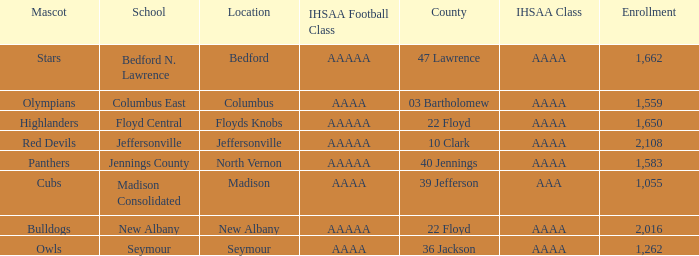What is bedford's mascot? Stars. Can you parse all the data within this table? {'header': ['Mascot', 'School', 'Location', 'IHSAA Football Class', 'County', 'IHSAA Class', 'Enrollment'], 'rows': [['Stars', 'Bedford N. Lawrence', 'Bedford', 'AAAAA', '47 Lawrence', 'AAAA', '1,662'], ['Olympians', 'Columbus East', 'Columbus', 'AAAA', '03 Bartholomew', 'AAAA', '1,559'], ['Highlanders', 'Floyd Central', 'Floyds Knobs', 'AAAAA', '22 Floyd', 'AAAA', '1,650'], ['Red Devils', 'Jeffersonville', 'Jeffersonville', 'AAAAA', '10 Clark', 'AAAA', '2,108'], ['Panthers', 'Jennings County', 'North Vernon', 'AAAAA', '40 Jennings', 'AAAA', '1,583'], ['Cubs', 'Madison Consolidated', 'Madison', 'AAAA', '39 Jefferson', 'AAA', '1,055'], ['Bulldogs', 'New Albany', 'New Albany', 'AAAAA', '22 Floyd', 'AAAA', '2,016'], ['Owls', 'Seymour', 'Seymour', 'AAAA', '36 Jackson', 'AAAA', '1,262']]} 